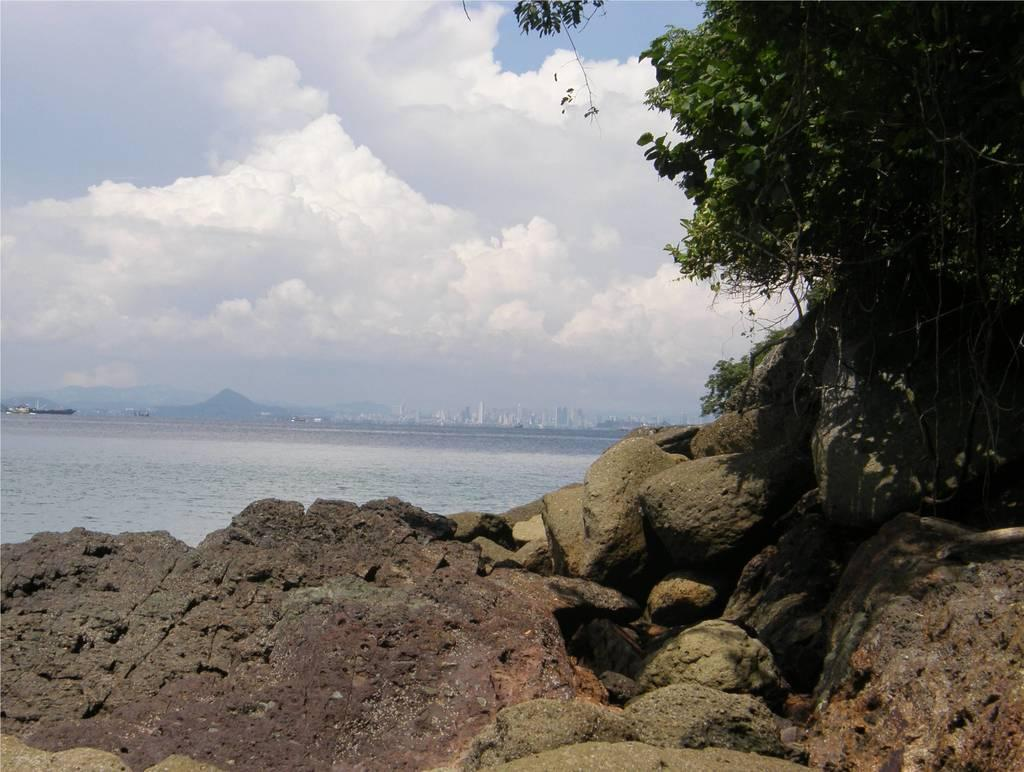What type of natural formation is present in the image? There are rocks in the image, extending from left to right. What type of plant can be seen on the right side of the image? There is a tree on the right side of the image. What is the liquid element visible in the image? Water is visible in the image. What type of man-made structures can be seen in the background of the image? There are buildings in the background of the image. What is the condition of the sky in the image? The sky is cloudy in the image. How many chairs are placed around the rocks in the image? There are no chairs present in the image; it features rocks, a tree, water, buildings, and a cloudy sky. 